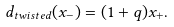Convert formula to latex. <formula><loc_0><loc_0><loc_500><loc_500>d _ { t w i s t e d } ( x _ { - } ) = ( 1 + q ) x _ { + } .</formula> 